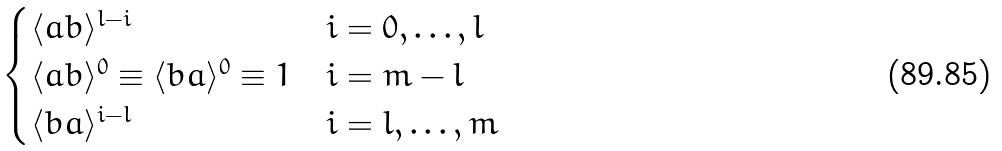Convert formula to latex. <formula><loc_0><loc_0><loc_500><loc_500>\begin{cases} \langle a b \rangle ^ { l - i } & i = 0 , \dots , l \\ \langle a b \rangle ^ { 0 } \equiv \langle b a \rangle ^ { 0 } \equiv 1 & i = m - l \\ \langle b a \rangle ^ { i - l } & i = l , \dots , m \end{cases}</formula> 